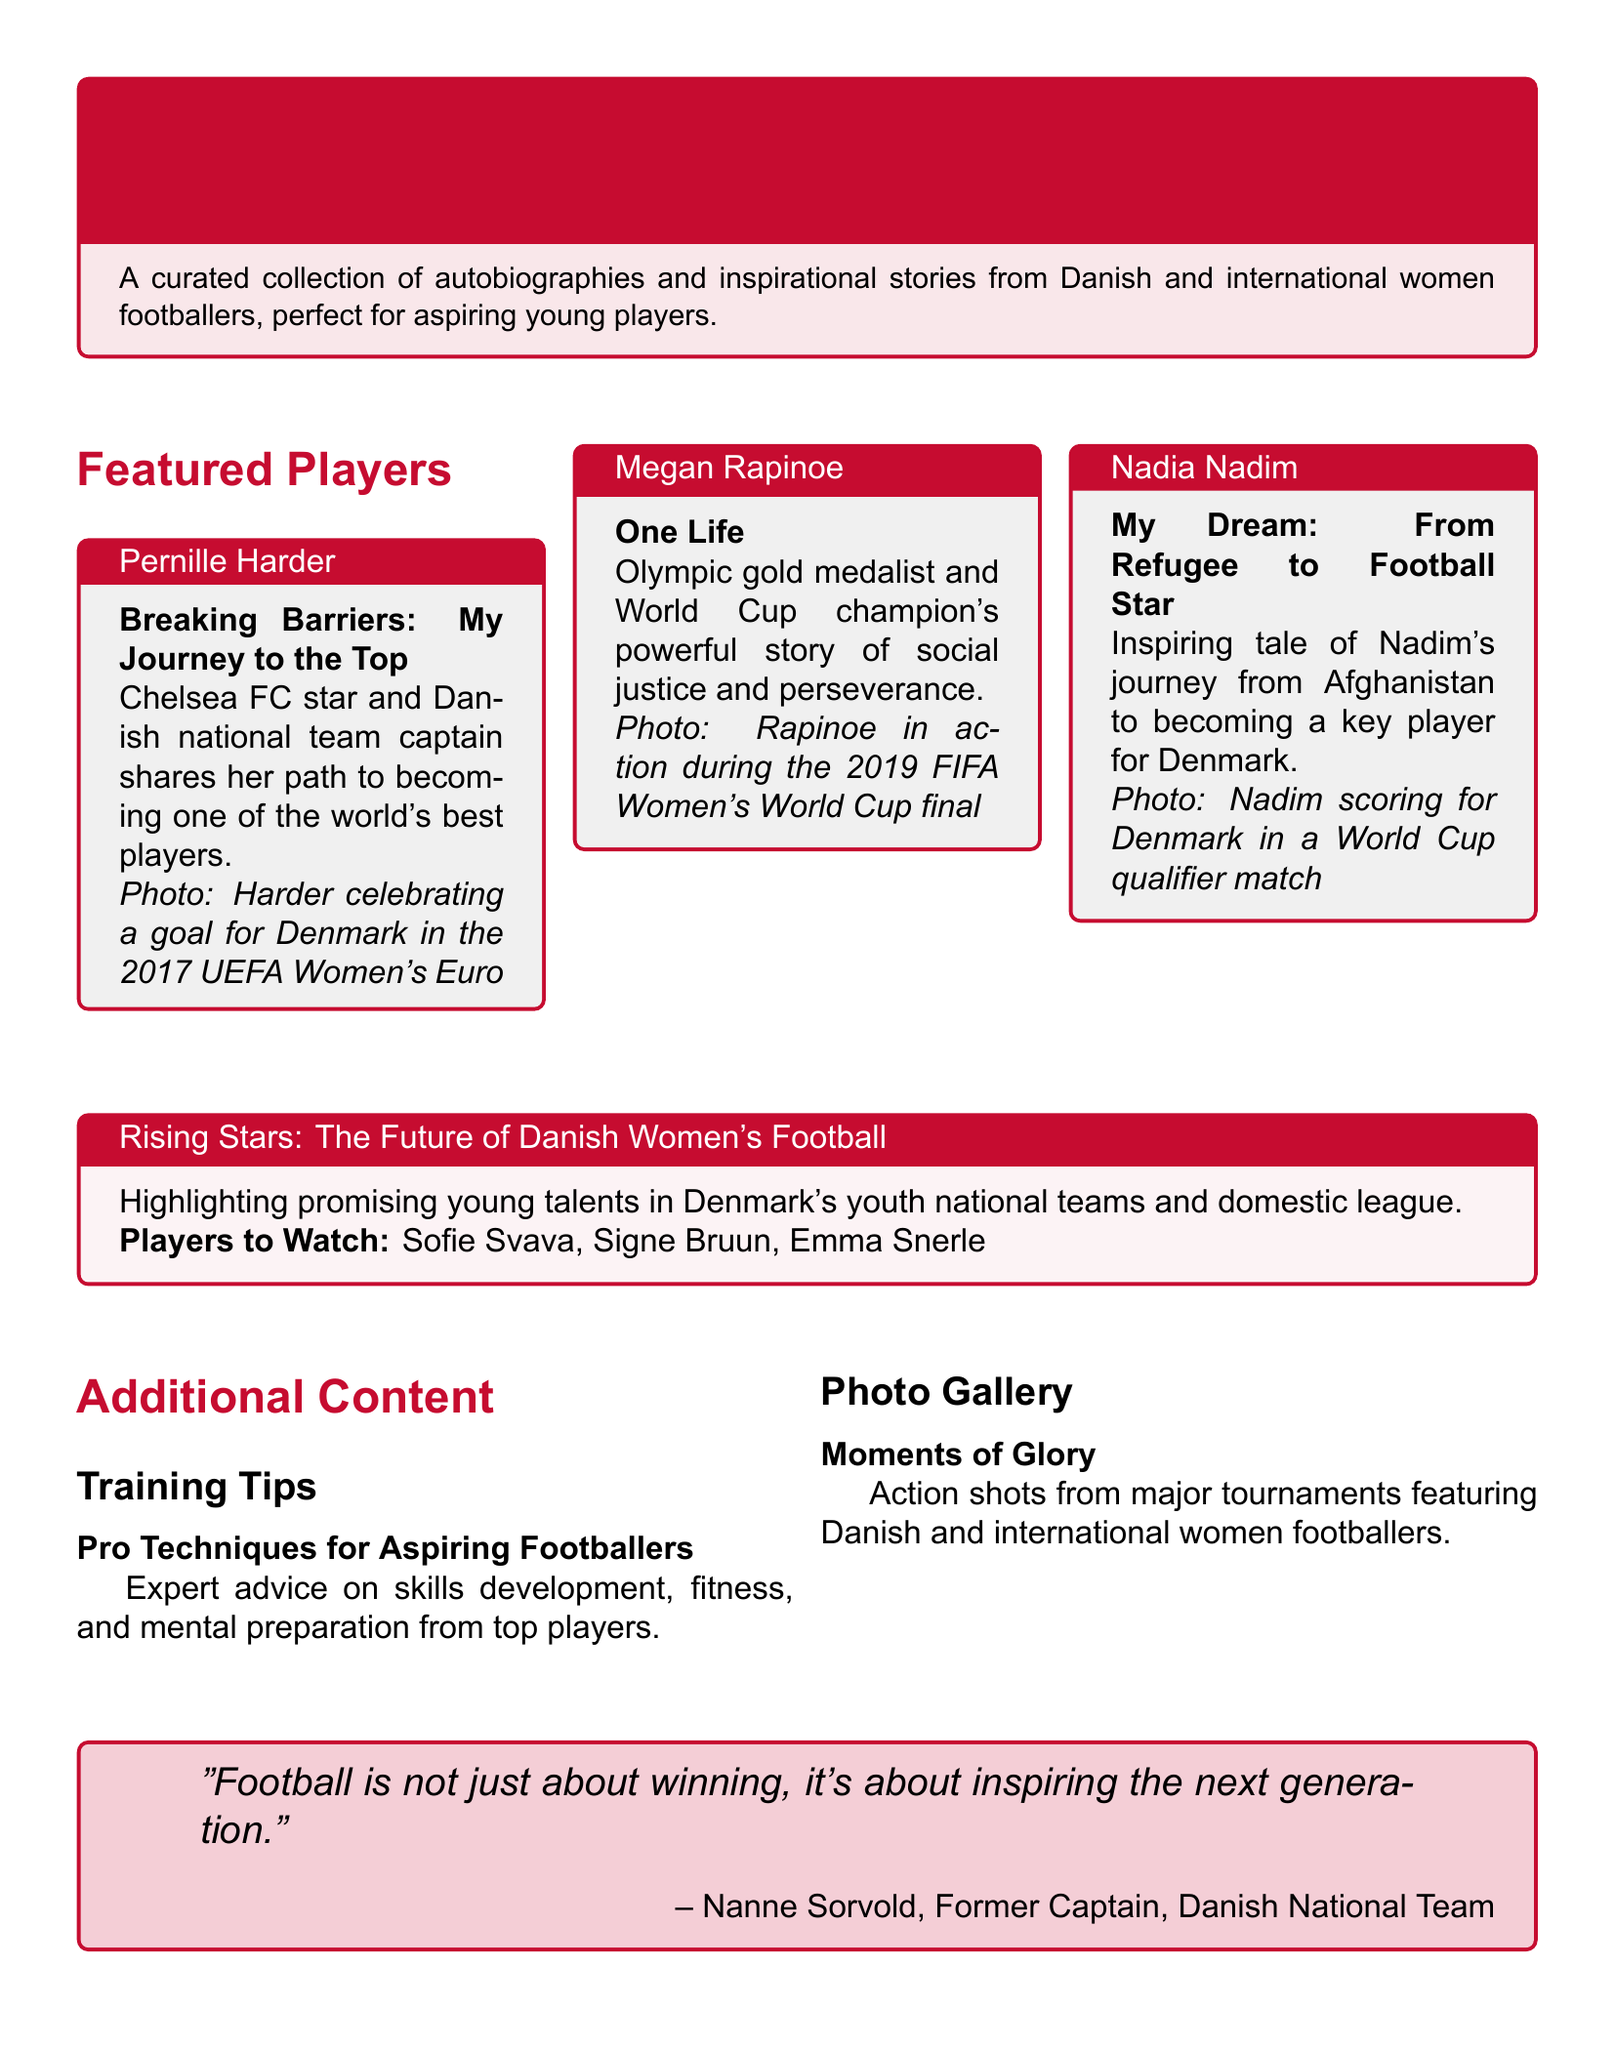What is the title of Pernille Harder's autobiography? The title is "Breaking Barriers: My Journey to the Top."
Answer: Breaking Barriers: My Journey to the Top Which club does Megan Rapinoe play for? The document does not specify a club for Megan Rapinoe, but she is known for playing with the US National Team and OL Reign.
Answer: OL Reign What inspiring journey does Nadia Nadim share? Nadia Nadim shares her journey from Afghanistan to becoming a key player for Denmark.
Answer: From Refugee to Football Star Who is highlighted as a rising star in Danish women's football? The document mentions Sofie Svava, Signe Bruun, and Emma Snerle as rising stars.
Answer: Sofie Svava, Signe Bruun, Emma Snerle What type of advice is provided in the "Training Tips" section? The training tips include expert advice on skills development, fitness, and mental preparation.
Answer: Skills development, fitness, and mental preparation What was the quote attributed to Nanne Sorvold about football? Nanne Sorvold's quote emphasizes inspiring the next generation.
Answer: "Football is not just about winning, it's about inspiring the next generation." What major international event is featured in the photo of Megan Rapinoe? The document mentions the 2019 FIFA Women's World Cup final as a major international event.
Answer: 2019 FIFA Women's World Cup final What is the primary theme of the document? The primary theme is women's football and inspirational stories from women footballers.
Answer: Inspiring Women in Football How many featured players are mentioned in the document? There are three featured players mentioned.
Answer: Three 